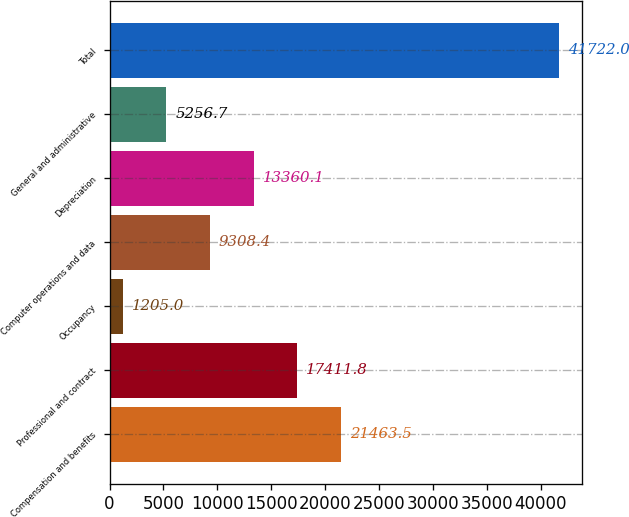Convert chart to OTSL. <chart><loc_0><loc_0><loc_500><loc_500><bar_chart><fcel>Compensation and benefits<fcel>Professional and contract<fcel>Occupancy<fcel>Computer operations and data<fcel>Depreciation<fcel>General and administrative<fcel>Total<nl><fcel>21463.5<fcel>17411.8<fcel>1205<fcel>9308.4<fcel>13360.1<fcel>5256.7<fcel>41722<nl></chart> 